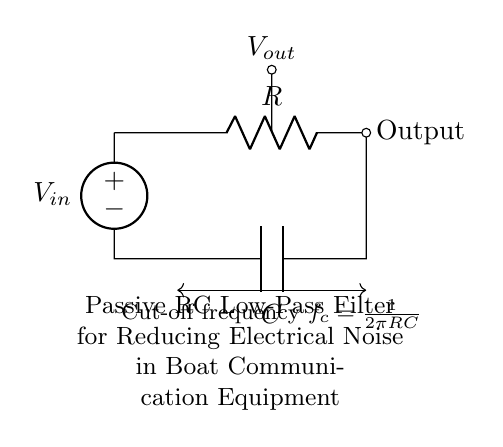What are the components in this circuit? The circuit contains a resistor, a capacitor, and a voltage source, which are clearly labeled.
Answer: Resistor, Capacitor, Voltage Source What is the output node labeled as in the diagram? The output node is marked as "Output", indicating where the output signal can be taken from the circuit.
Answer: Output What is the purpose of this RC low-pass filter? The purpose is to reduce electrical noise in boat communication equipment, which is explicitly stated in the circuit description.
Answer: Reduce electrical noise What does the cut-off frequency formula represent in this circuit? The cut-off frequency formula indicates the frequency at which the output voltage is decreased by 3 dB, determining how effectively the filter can block high-frequency signals.
Answer: Cut-off frequency How does increasing the resistor value affect the cut-off frequency? Increasing the resistor value will lower the cut-off frequency, since the formula indicates that cut-off frequency is inversely proportional to R.
Answer: Lowers the cut-off frequency What happens to the output voltage when the input frequency exceeds the cut-off frequency? The output voltage will significantly decrease when the input frequency exceeds the cut-off frequency, attenuating high-frequency signals.
Answer: Decreases significantly 